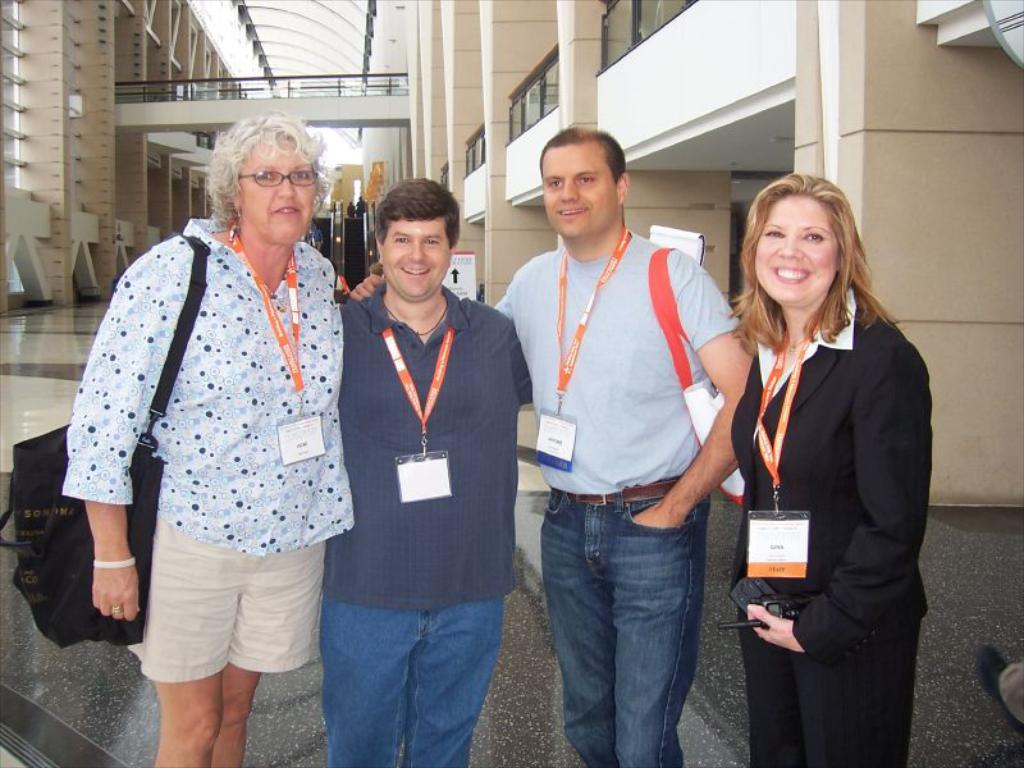How many people are present in the image? There are four people standing in the image. What is the facial expression of the people in the image? The people are smiling. What do the people have that is visible in the image? The people have ID cards. What is the woman holding in the image? A woman is holding an object. What architectural features can be seen in the background of the image? There are pillars, a board, a roof, and a railing in the background of the image. What type of ball is being used to destroy the authority in the image? There is no ball or destruction of authority present in the image. 